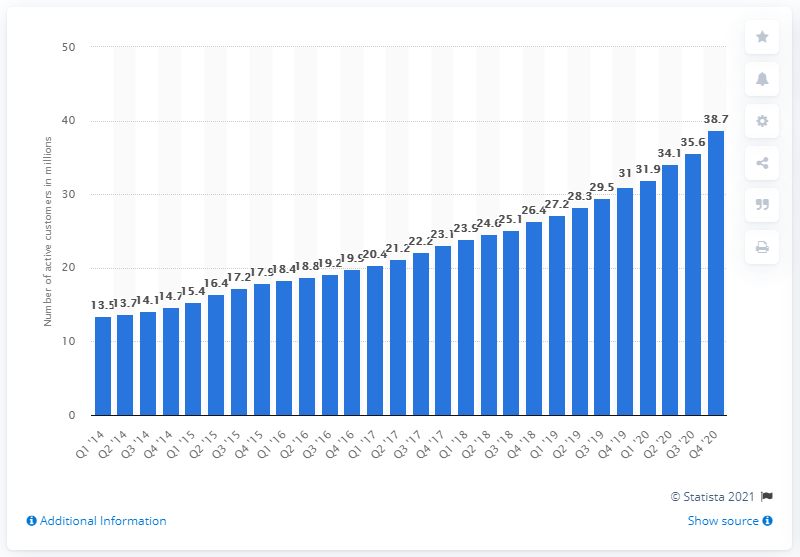Outline some significant characteristics in this image. Zalando added 38.7 customers in the first quarter of 2020. Zalando's website received orders from 38,700 customers in the last 12 months leading up to December 31, 2020. 